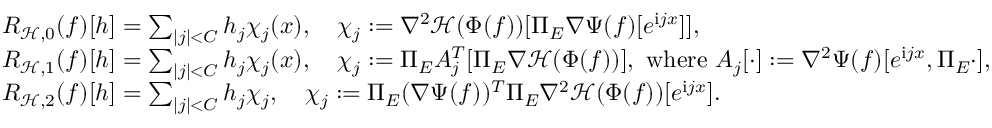Convert formula to latex. <formula><loc_0><loc_0><loc_500><loc_500>\begin{array} { r l } & { R _ { \mathcal { H } , 0 } ( f ) [ h ] = \sum _ { | j | < C } h _ { j } \chi _ { j } ( x ) , \quad \chi _ { j } \colon = \nabla ^ { 2 } \mathcal { H } ( \Phi ( f ) ) [ \Pi _ { E } \nabla \Psi ( f ) [ e ^ { i j x } ] ] , } \\ & { R _ { \mathcal { H } , 1 } ( f ) [ h ] = \sum _ { | j | < C } h _ { j } \chi _ { j } ( x ) , \quad \chi _ { j } \colon = \Pi _ { E } A _ { j } ^ { T } [ \Pi _ { E } \nabla \mathcal { H } ( \Phi ( f ) ) ] , w h e r e A _ { j } [ \cdot ] \colon = \nabla ^ { 2 } \Psi ( f ) [ e ^ { i j x } , \Pi _ { E } \cdot ] , } \\ & { R _ { \mathcal { H } , 2 } ( f ) [ h ] = \sum _ { | j | < C } h _ { j } \chi _ { j } , \quad \chi _ { j } \colon = \Pi _ { E } ( \nabla \Psi ( f ) ) ^ { T } \Pi _ { E } \nabla ^ { 2 } \mathcal { H } ( \Phi ( f ) ) [ e ^ { i j x } ] . } \end{array}</formula> 